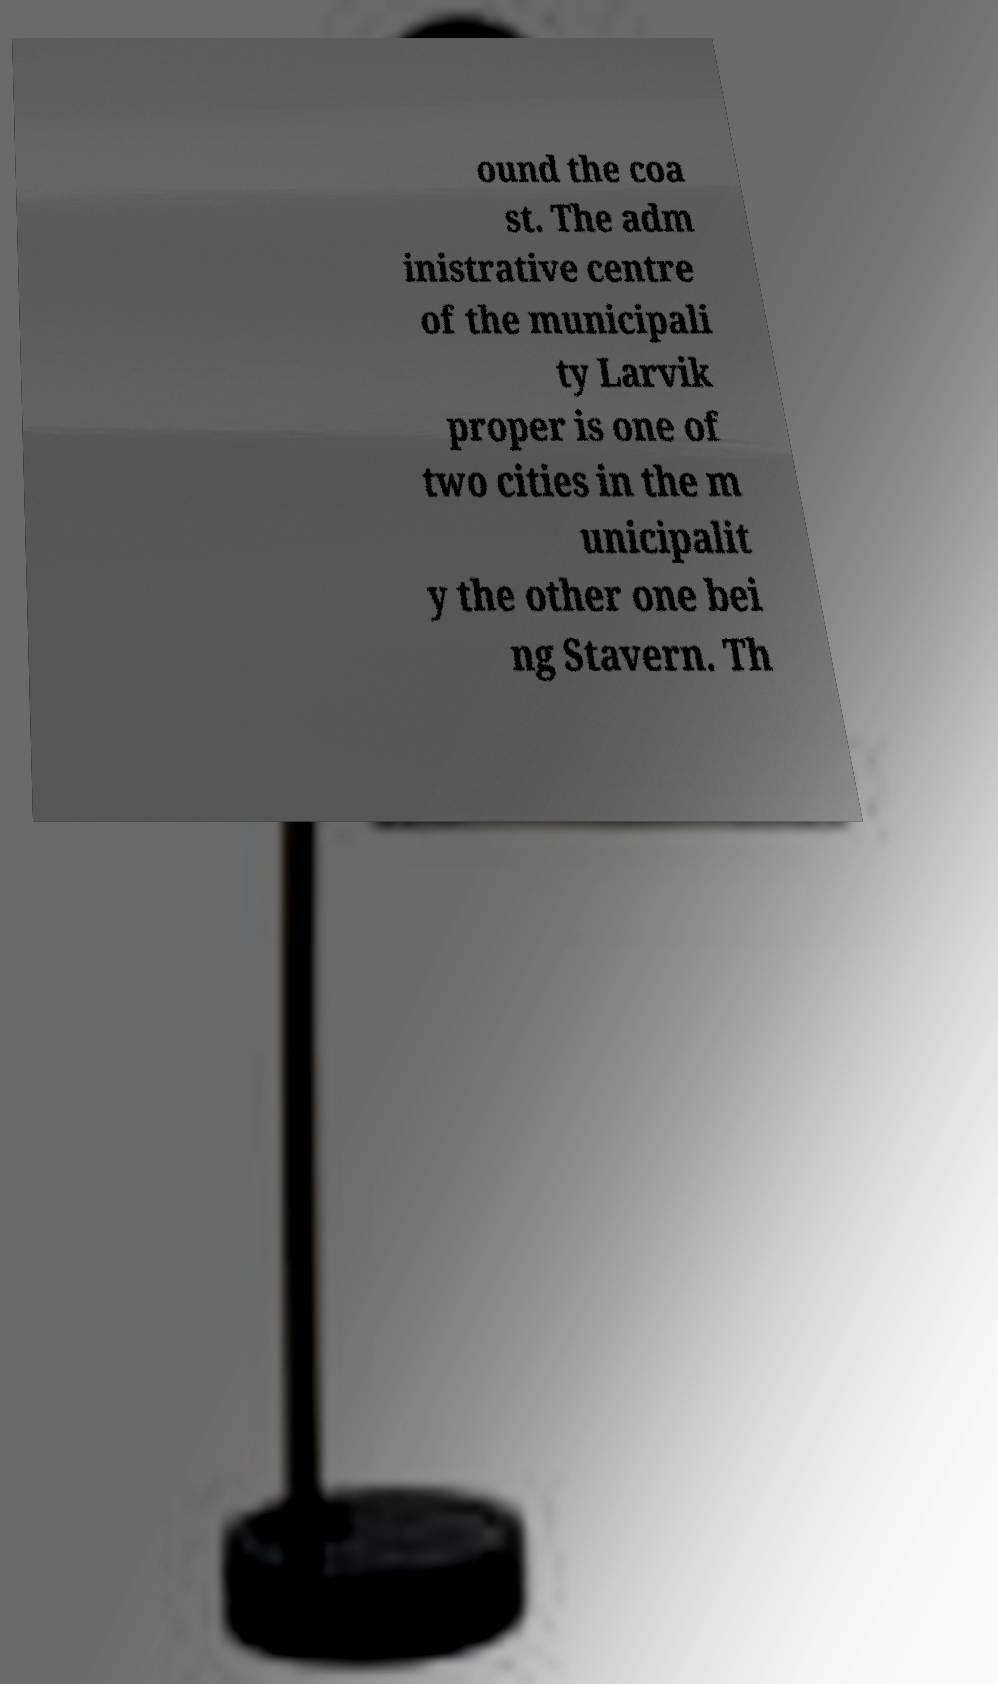Could you assist in decoding the text presented in this image and type it out clearly? ound the coa st. The adm inistrative centre of the municipali ty Larvik proper is one of two cities in the m unicipalit y the other one bei ng Stavern. Th 